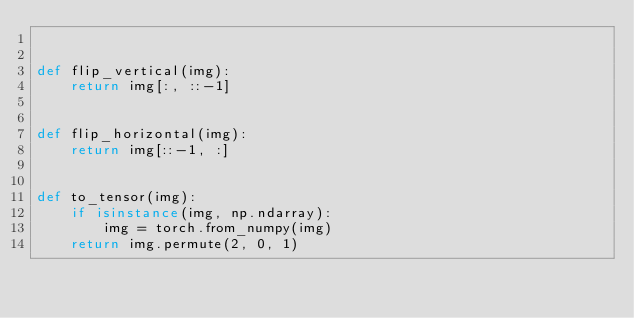<code> <loc_0><loc_0><loc_500><loc_500><_Python_>

def flip_vertical(img):
    return img[:, ::-1]


def flip_horizontal(img):
    return img[::-1, :]


def to_tensor(img):
    if isinstance(img, np.ndarray):
        img = torch.from_numpy(img)
    return img.permute(2, 0, 1)
</code> 